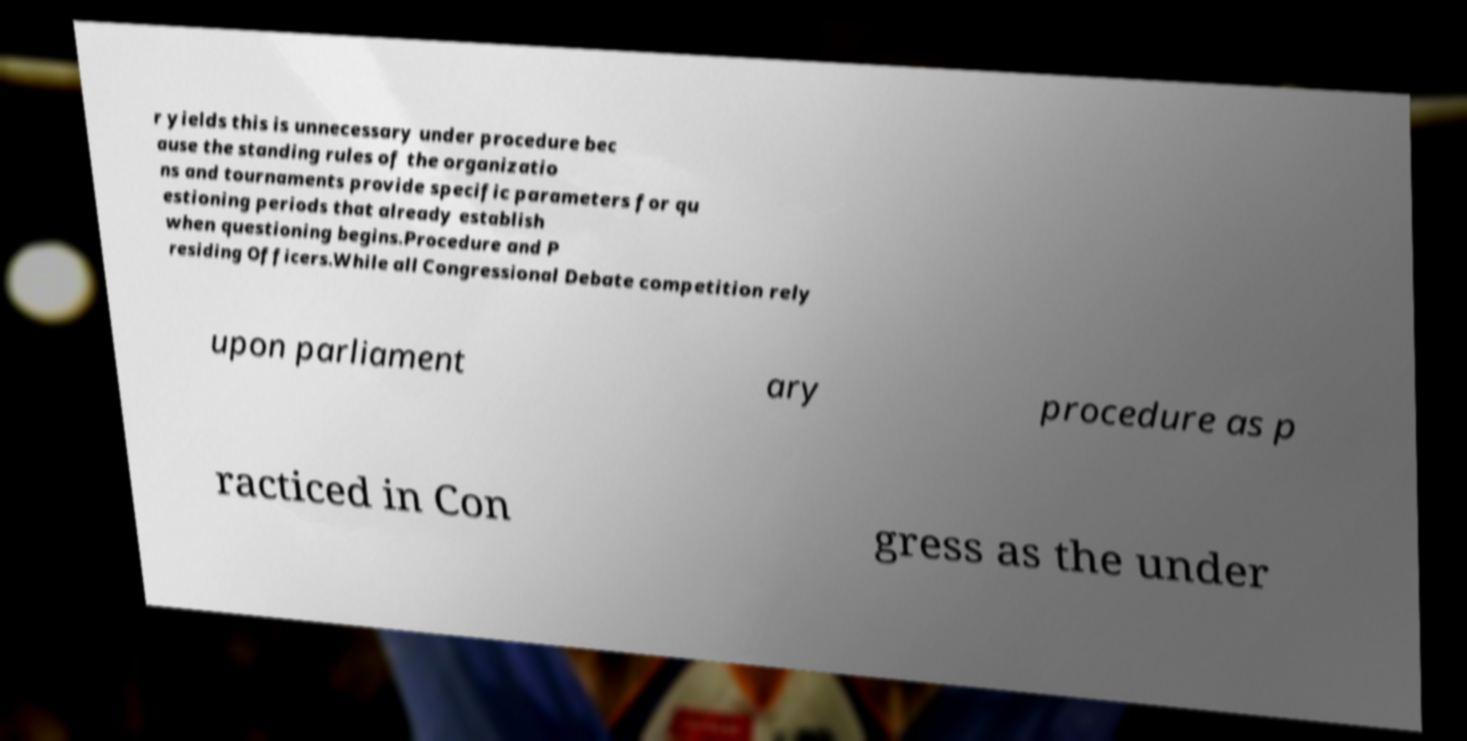Please identify and transcribe the text found in this image. r yields this is unnecessary under procedure bec ause the standing rules of the organizatio ns and tournaments provide specific parameters for qu estioning periods that already establish when questioning begins.Procedure and P residing Officers.While all Congressional Debate competition rely upon parliament ary procedure as p racticed in Con gress as the under 